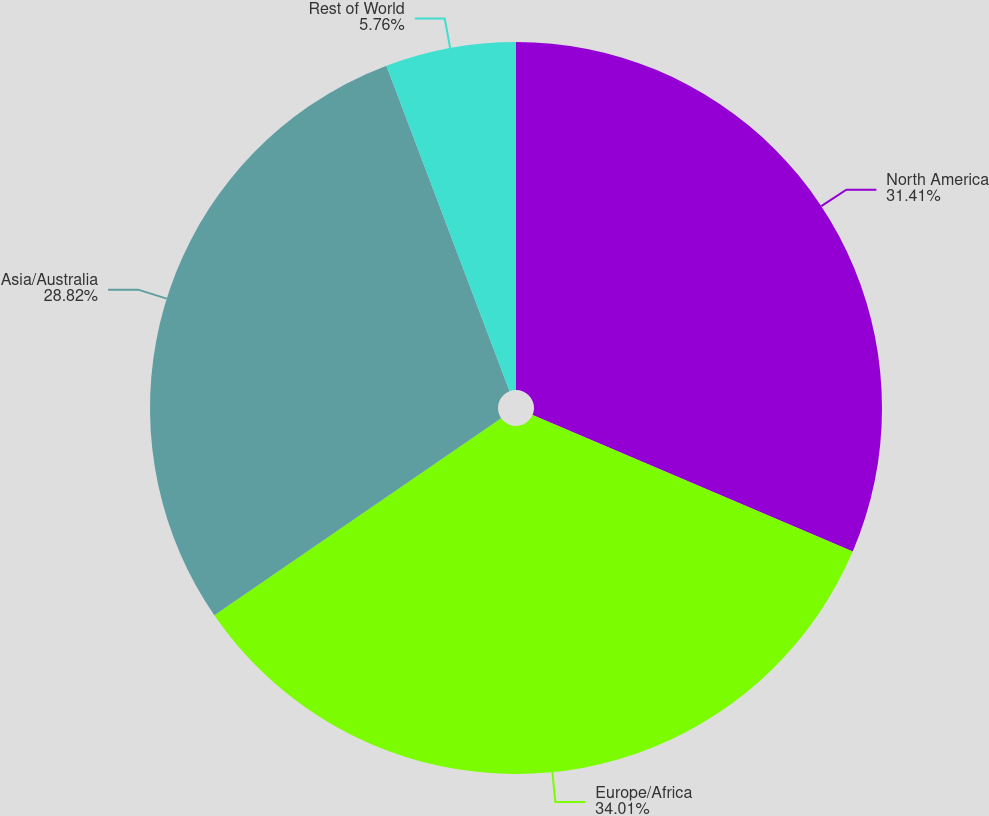Convert chart. <chart><loc_0><loc_0><loc_500><loc_500><pie_chart><fcel>North America<fcel>Europe/Africa<fcel>Asia/Australia<fcel>Rest of World<nl><fcel>31.41%<fcel>34.01%<fcel>28.82%<fcel>5.76%<nl></chart> 